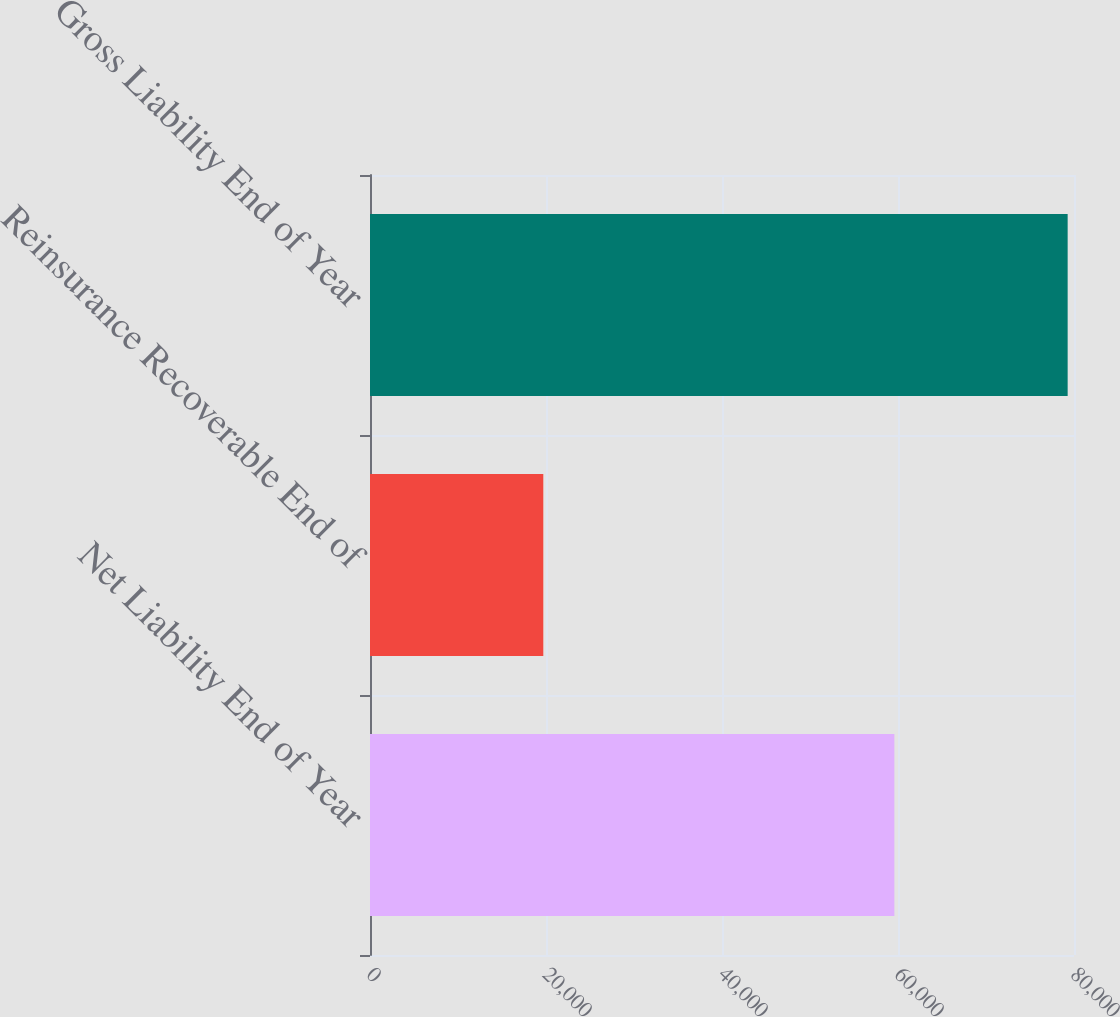Convert chart to OTSL. <chart><loc_0><loc_0><loc_500><loc_500><bar_chart><fcel>Net Liability End of Year<fcel>Reinsurance Recoverable End of<fcel>Gross Liability End of Year<nl><fcel>59586<fcel>19693<fcel>79279<nl></chart> 